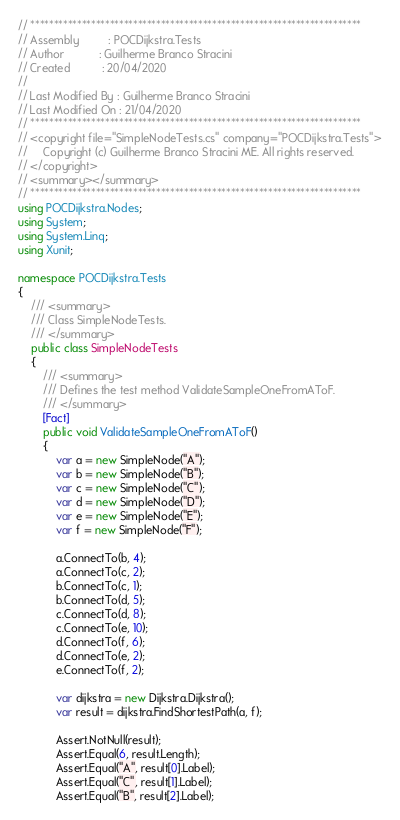Convert code to text. <code><loc_0><loc_0><loc_500><loc_500><_C#_>// ***********************************************************************
// Assembly         : POCDijkstra.Tests
// Author           : Guilherme Branco Stracini
// Created          : 20/04/2020
//
// Last Modified By : Guilherme Branco Stracini
// Last Modified On : 21/04/2020
// ***********************************************************************
// <copyright file="SimpleNodeTests.cs" company="POCDijkstra.Tests">
//     Copyright (c) Guilherme Branco Stracini ME. All rights reserved.
// </copyright>
// <summary></summary>
// ***********************************************************************
using POCDijkstra.Nodes;
using System;
using System.Linq;
using Xunit;

namespace POCDijkstra.Tests
{
    /// <summary>
    /// Class SimpleNodeTests.
    /// </summary>
    public class SimpleNodeTests
    {
        /// <summary>
        /// Defines the test method ValidateSampleOneFromAToF.
        /// </summary>
        [Fact]
        public void ValidateSampleOneFromAToF()
        {
            var a = new SimpleNode("A");
            var b = new SimpleNode("B");
            var c = new SimpleNode("C");
            var d = new SimpleNode("D");
            var e = new SimpleNode("E");
            var f = new SimpleNode("F");

            a.ConnectTo(b, 4);
            a.ConnectTo(c, 2);
            b.ConnectTo(c, 1);
            b.ConnectTo(d, 5);
            c.ConnectTo(d, 8);
            c.ConnectTo(e, 10);
            d.ConnectTo(f, 6);
            d.ConnectTo(e, 2);
            e.ConnectTo(f, 2);

            var dijkstra = new Dijkstra.Dijkstra();
            var result = dijkstra.FindShortestPath(a, f);

            Assert.NotNull(result);
            Assert.Equal(6, result.Length);
            Assert.Equal("A", result[0].Label);
            Assert.Equal("C", result[1].Label);
            Assert.Equal("B", result[2].Label);</code> 